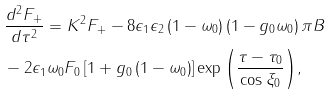<formula> <loc_0><loc_0><loc_500><loc_500>& \frac { d ^ { 2 } F _ { + } } { d \tau ^ { 2 } } = K ^ { 2 } F _ { + } - 8 \epsilon _ { 1 } \epsilon _ { 2 } \left ( 1 - \omega _ { 0 } \right ) \left ( 1 - g _ { 0 } \omega _ { 0 } \right ) \pi B \\ & - 2 \epsilon _ { 1 } \omega _ { 0 } F _ { 0 } \left [ 1 + g _ { 0 } \left ( 1 - \omega _ { 0 } \right ) \right ] \exp { \left ( \frac { \tau - \tau _ { 0 } } { \cos \xi _ { 0 } } \right ) } ,</formula> 